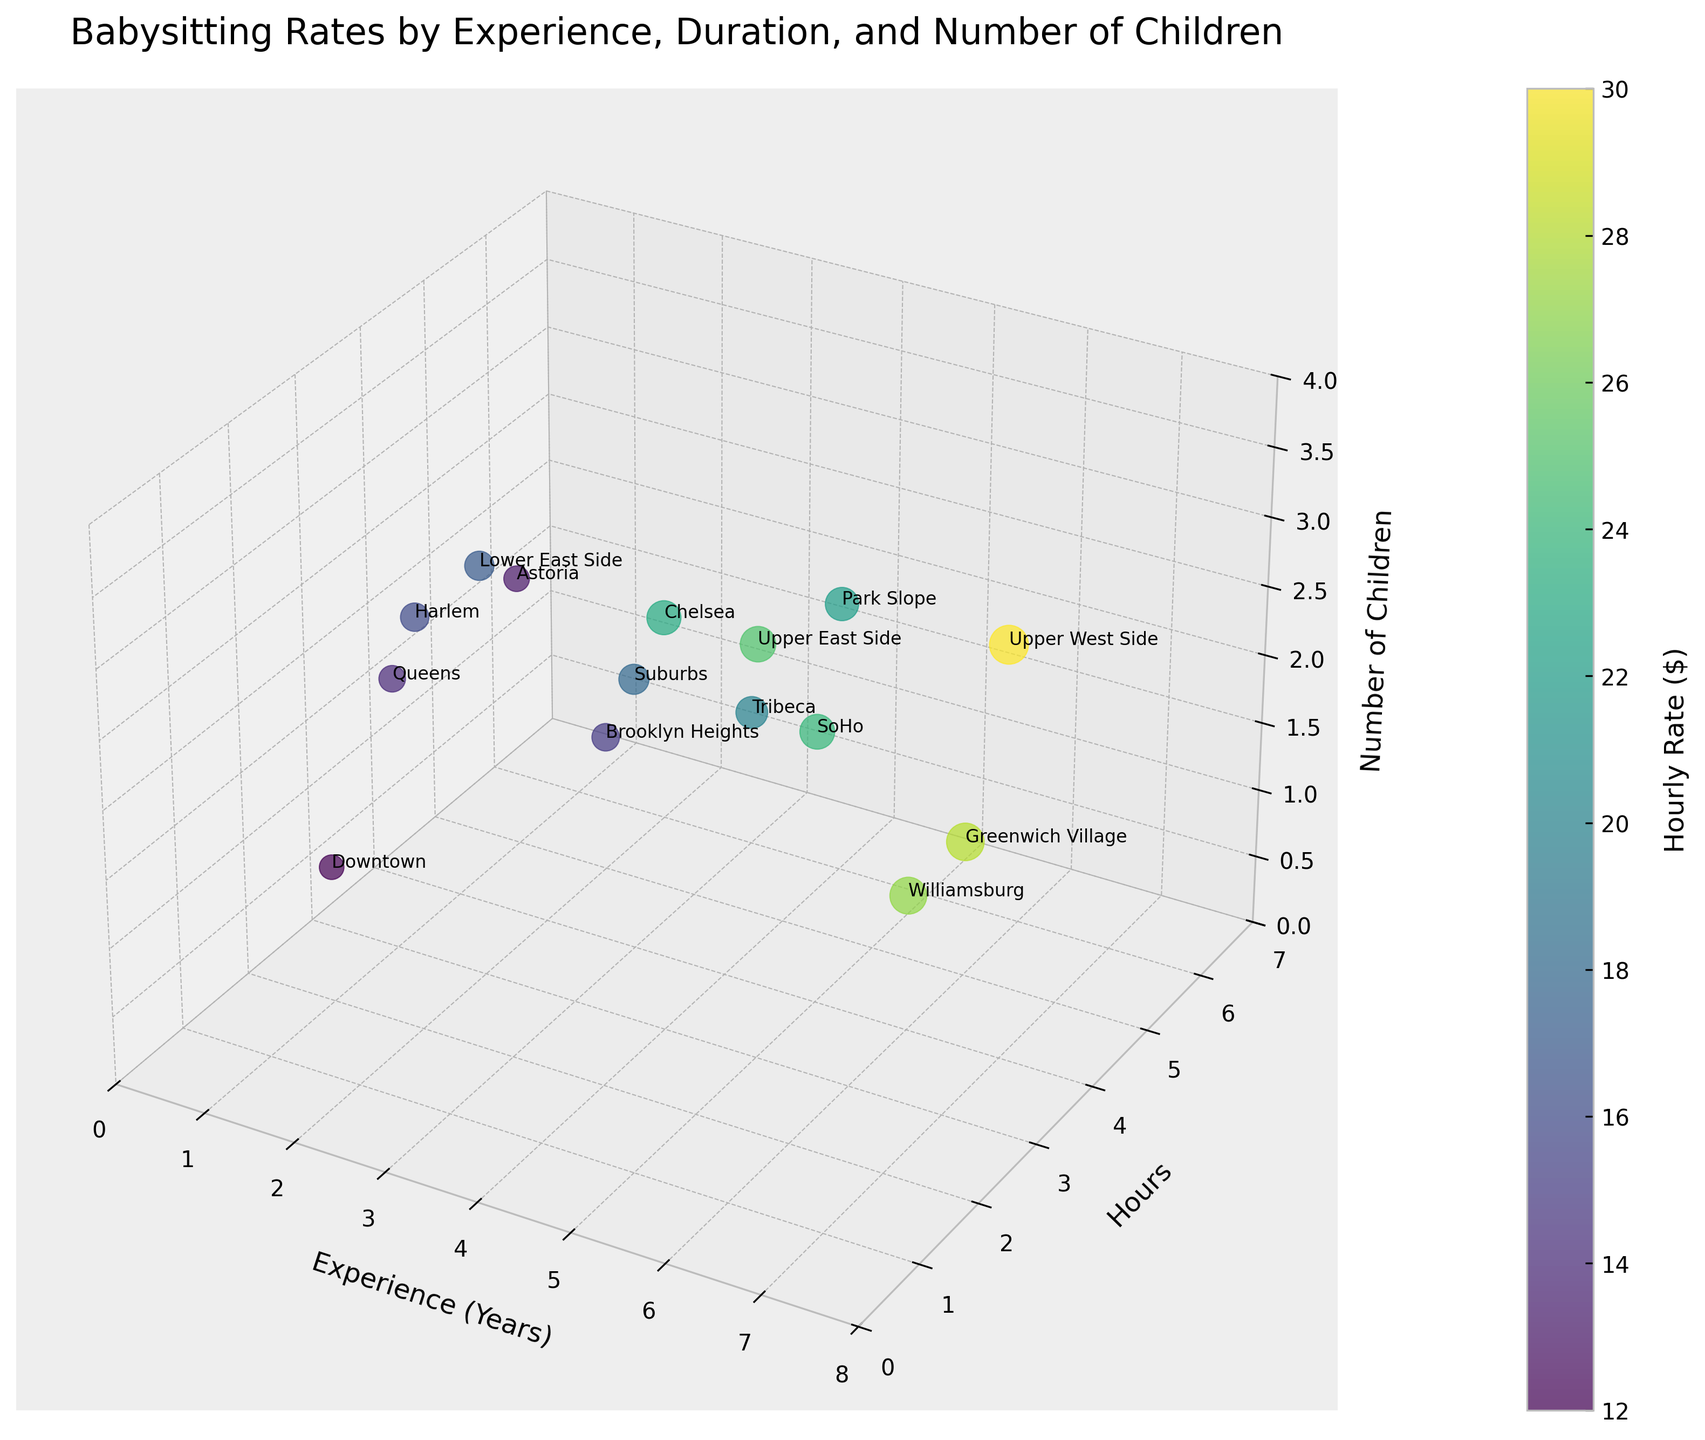What's the title of the figure? The title is displayed at the top of the figure in larger font indicating what the plot represents visually.
Answer: Babysitting Rates by Experience, Duration, and Number of Children How many different neighborhoods are represented in the figure? Each neighborhood is labeled by a name next to the respective data point in the plot. Count the number of different labels mentioned.
Answer: 15 Which neighborhood has the highest hourly rate? Identify the location in the plot with the largest value on the color bar. Read the label of the closest data point to this highest rate.
Answer: Upper West Side Which data point represents a babysitter with the most experience and caring for three children? Look for the highest point on the 'Experience (Years)' axis (x-axis) that also aligns with the 'Number of Children' axis (z-axis) value of 3. Then, check the neighborhood label next to this point.
Answer: Upper West Side What neighborhood has an hourly rate of $27? Find the data point that corresponds to the color representing $27 on the color bar. Read the label next to this point.
Answer: Williamsburg How many hours does the babysitter in Chelsea work? Locate the data point labeled ‘Chelsea’. Read the value on the 'Hours' axis (y-axis) corresponding to this point.
Answer: 3 hours What is the relationship between experience and hourly rate in Greenwich Village? Identify the data point representing Greenwich Village. Observe how the hourly rate color and the experience level in years (x-axis) relate at this point.
Answer: Higher experience tends to have a higher hourly rate Compare the babysitting rates of Brooklyn Heights and Lower East Side. Which one is higher? Locate the data points representing Brooklyn Heights and Lower East Side. Compare the color of each point based on the color bar.
Answer: Brooklyn Heights has a higher rate Which neighborhood has a rate less than $15 and takes care of 1 child? Find the data point among those with the color representing less than $15 and that aligns with 1 on the 'Number of Children' axis (z-axis). Read the neighborhood label.
Answer: Downtown Are there more high-paying rates associated with longer hours or more experience? Observe if the higher rates (darker colors) tend to appear more for points with higher 'Experience (Years)' on the x-axis or higher 'Hours' on the y-axis.
Answer: More experience 